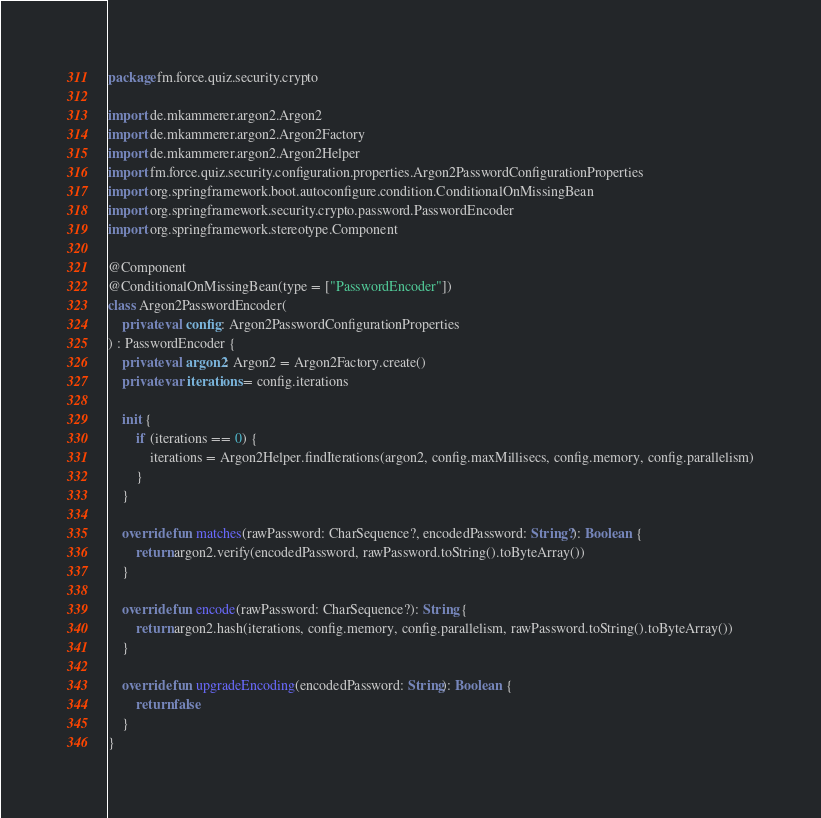Convert code to text. <code><loc_0><loc_0><loc_500><loc_500><_Kotlin_>package fm.force.quiz.security.crypto

import de.mkammerer.argon2.Argon2
import de.mkammerer.argon2.Argon2Factory
import de.mkammerer.argon2.Argon2Helper
import fm.force.quiz.security.configuration.properties.Argon2PasswordConfigurationProperties
import org.springframework.boot.autoconfigure.condition.ConditionalOnMissingBean
import org.springframework.security.crypto.password.PasswordEncoder
import org.springframework.stereotype.Component

@Component
@ConditionalOnMissingBean(type = ["PasswordEncoder"])
class Argon2PasswordEncoder(
    private val config: Argon2PasswordConfigurationProperties
) : PasswordEncoder {
    private val argon2: Argon2 = Argon2Factory.create()
    private var iterations = config.iterations

    init {
        if (iterations == 0) {
            iterations = Argon2Helper.findIterations(argon2, config.maxMillisecs, config.memory, config.parallelism)
        }
    }

    override fun matches(rawPassword: CharSequence?, encodedPassword: String?): Boolean {
        return argon2.verify(encodedPassword, rawPassword.toString().toByteArray())
    }

    override fun encode(rawPassword: CharSequence?): String {
        return argon2.hash(iterations, config.memory, config.parallelism, rawPassword.toString().toByteArray())
    }

    override fun upgradeEncoding(encodedPassword: String): Boolean {
        return false
    }
}
</code> 